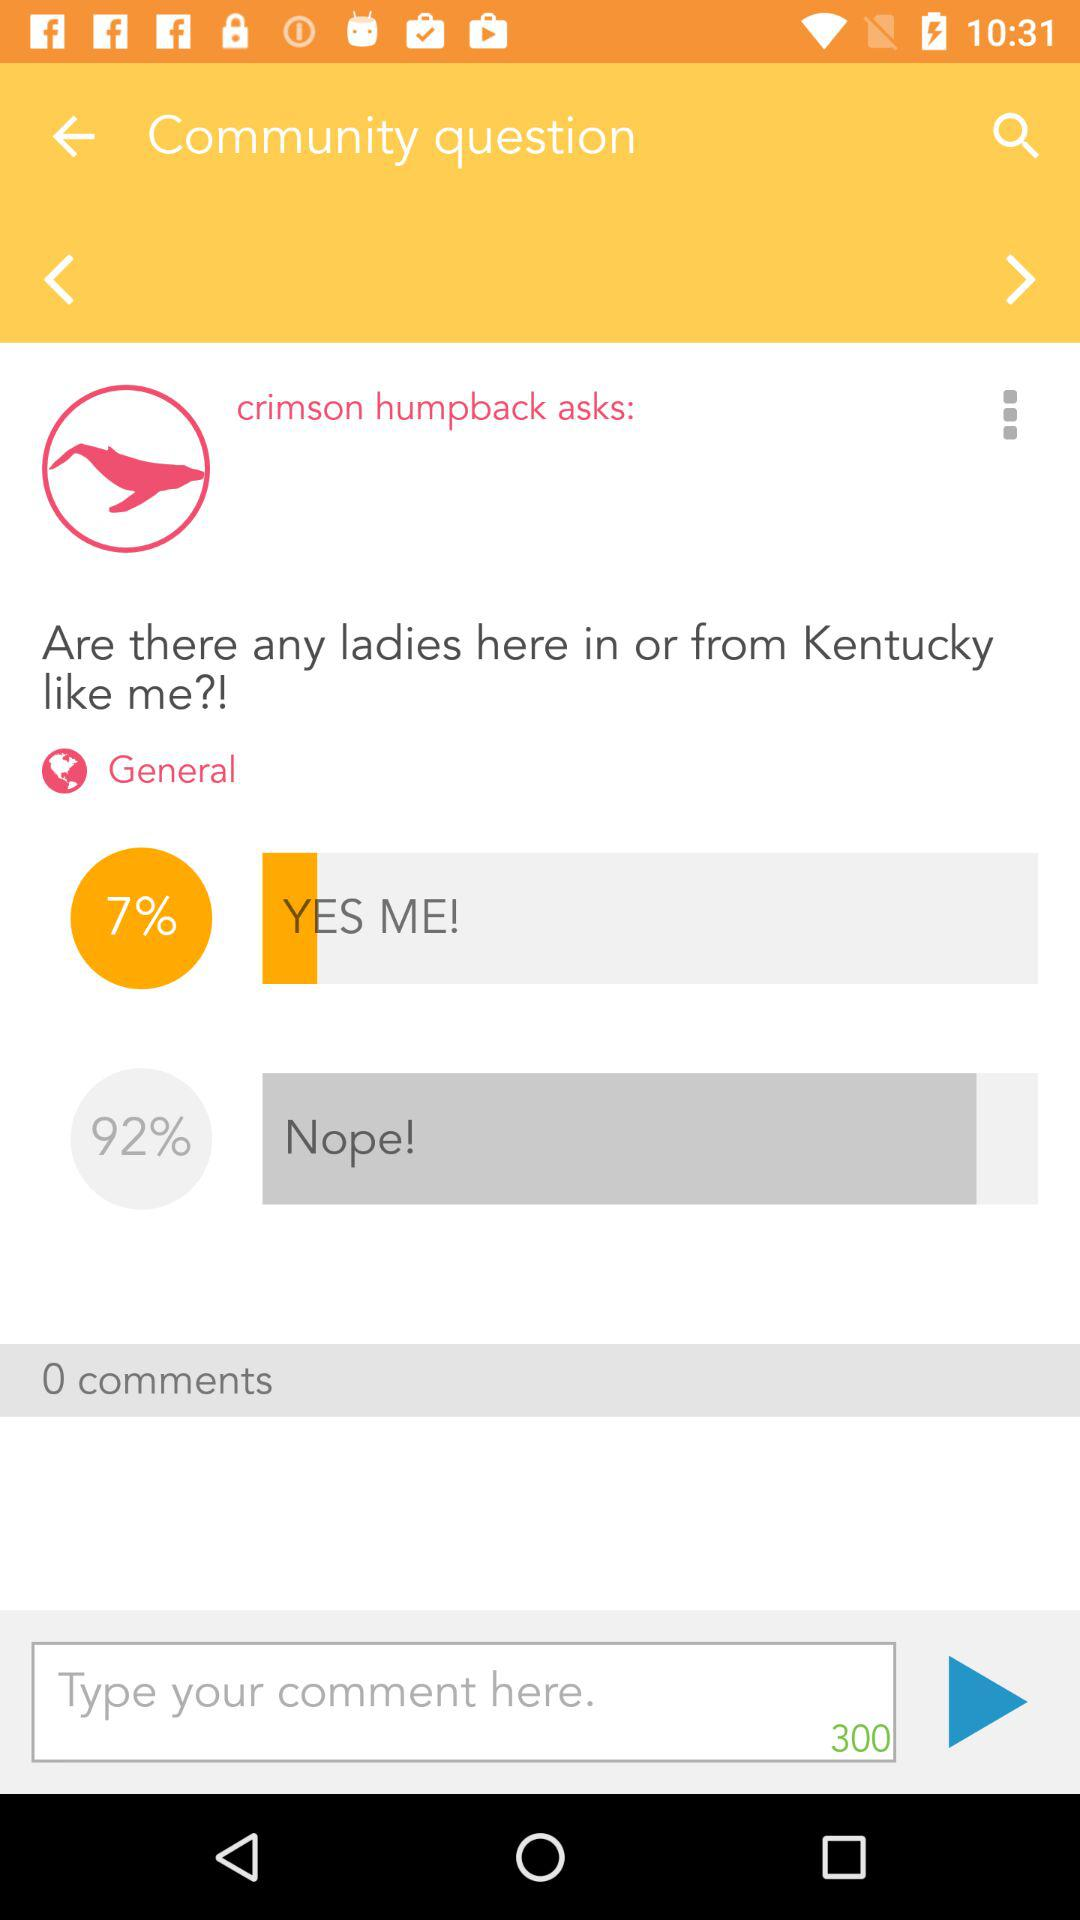How many of the ladies are from Kentucky? There are 7% of ladies who are from Kentucky. 